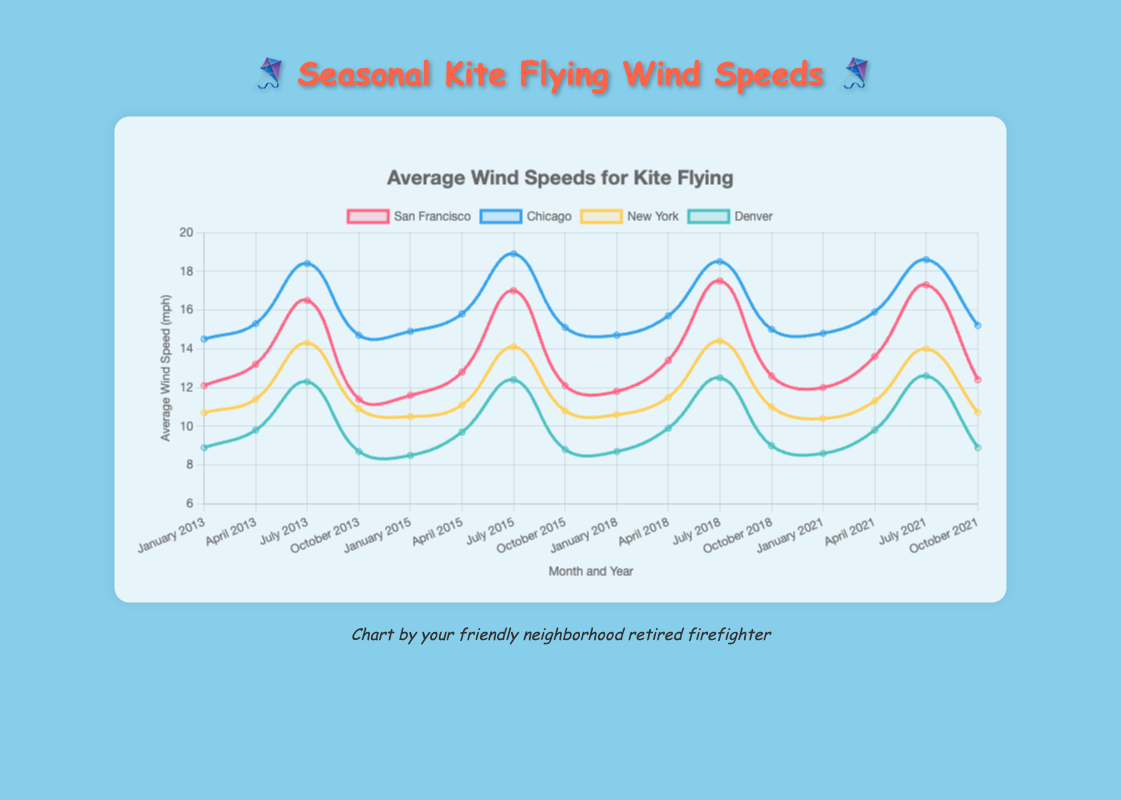Which city has the highest average wind speed in July 2021? Look at the data points and find the line representing July 2021 for each city. Identify the one with the highest value.
Answer: Chicago Which city had the least wind speed in January 2018? Find the data points for January 2018 in each city's line and identify the one with the lowest value.
Answer: New York In San Francisco, by how much did the average wind speed increase from January 2013 to July 2013? Subtract the average wind speed of January 2013 from that of July 2013 for San Francisco.
Answer: 4.4 mph Compare the average wind speeds in July 2018 between New York and Denver. Which city had a higher wind speed and by how much? Compare the data points for July 2018 for both cities and subtract the lower wind speed from the higher one.
Answer: New York by 1.9 mph What's the overall trend in wind speed in Chicago during the month of October from 2013 to 2021? Plot the points for October from 2013 to 2021 for Chicago and describe the trend direction (increasing, decreasing).
Answer: Slightly increasing Which city showed the most consistent wind speeds across the years in April? Look at the lines for April across the years for each city and compare the variability. The city with the least fluctuation is the answer.
Answer: San Francisco By how much does the wind speed in Denver in October 2021 differ from that in April 2021? Subtract the wind speed in October 2021 from that in April 2021 for Denver.
Answer: -0.9 mph What was the highest wind speed recorded in New York and in which month and year did it occur? Check all data points for New York and identify the highest value along with its corresponding month and year.
Answer: July 2018, 14.4 mph Which city experienced the largest increase in wind speed between April and July in any year? Calculate the increase in wind speed from April to July for each year and city, then find the largest difference.
Answer: Chicago in 2013, 3.1 mph How does the average wind speed in San Francisco in January 2021 compare to that in January 2013? Compare the data points for January 2021 and January 2013 in San Francisco.
Answer: 12.0 mph vs 12.1 mph (roughly the same) 